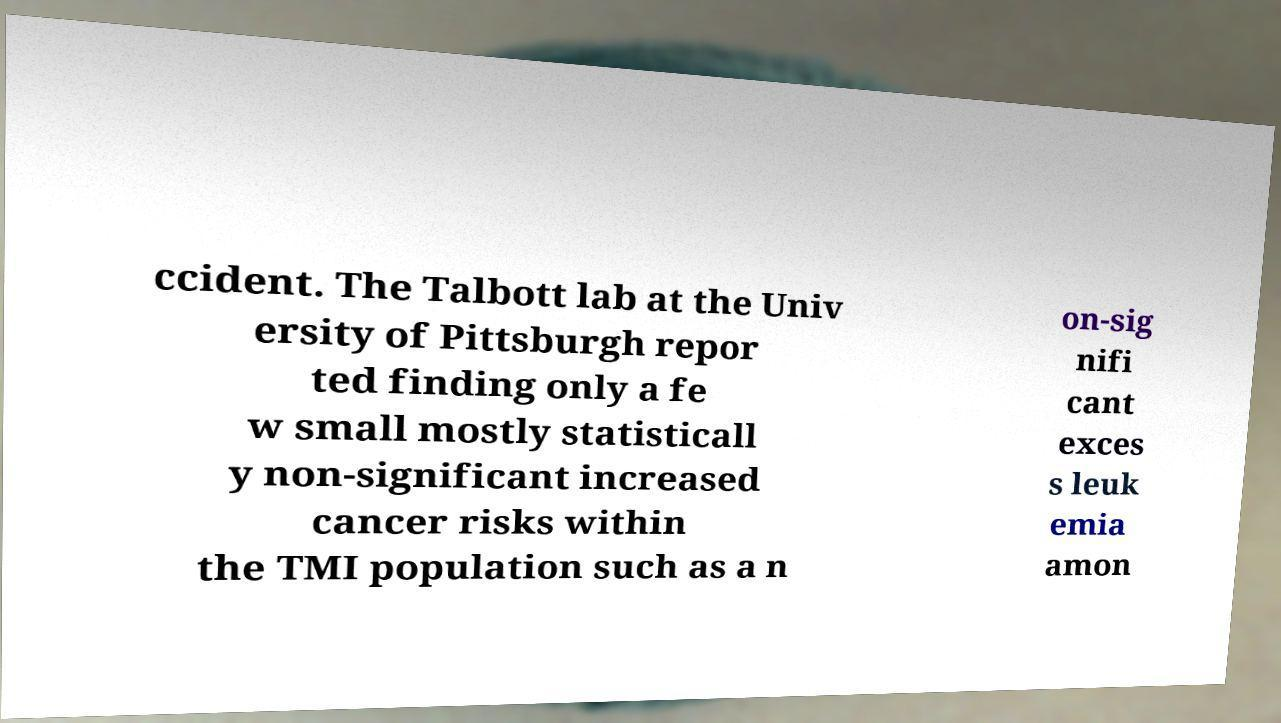Could you assist in decoding the text presented in this image and type it out clearly? ccident. The Talbott lab at the Univ ersity of Pittsburgh repor ted finding only a fe w small mostly statisticall y non-significant increased cancer risks within the TMI population such as a n on-sig nifi cant exces s leuk emia amon 